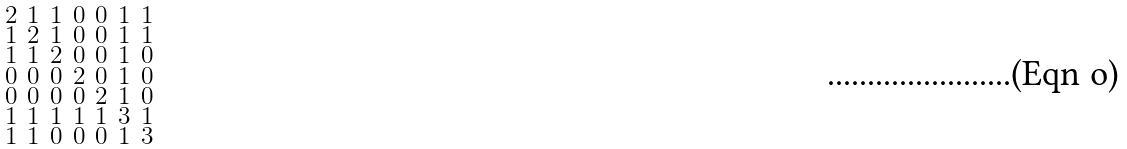Convert formula to latex. <formula><loc_0><loc_0><loc_500><loc_500>\begin{smallmatrix} 2 & 1 & 1 & 0 & 0 & 1 & 1 \\ 1 & 2 & 1 & 0 & 0 & 1 & 1 \\ 1 & 1 & 2 & 0 & 0 & 1 & 0 \\ 0 & 0 & 0 & 2 & 0 & 1 & 0 \\ 0 & 0 & 0 & 0 & 2 & 1 & 0 \\ 1 & 1 & 1 & 1 & 1 & 3 & 1 \\ 1 & 1 & 0 & 0 & 0 & 1 & 3 \end{smallmatrix}</formula> 